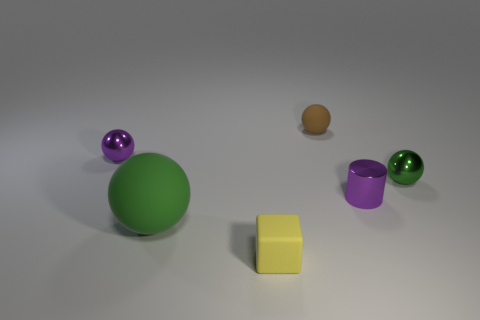Subtract all big balls. How many balls are left? 3 Subtract 3 spheres. How many spheres are left? 1 Subtract all green balls. How many balls are left? 2 Subtract all cubes. How many objects are left? 5 Add 1 purple metallic cylinders. How many objects exist? 7 Add 6 yellow cubes. How many yellow cubes are left? 7 Add 1 small green spheres. How many small green spheres exist? 2 Subtract 0 gray blocks. How many objects are left? 6 Subtract all green spheres. Subtract all blue cylinders. How many spheres are left? 2 Subtract all purple spheres. How many purple blocks are left? 0 